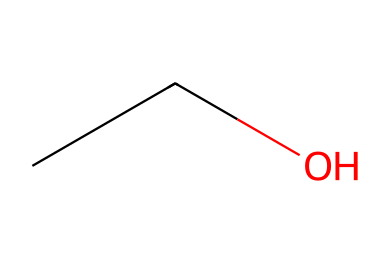What is the full name of this chemical? The SMILES representation "CCO" corresponds to the chemical structure of ethanol, which consists of two carbon atoms, five hydrogen atoms, and one oxygen atom.
Answer: ethanol How many carbon atoms are in this structure? The SMILES "CCO" indicates there are two 'C' characters, representing two carbon atoms in the structure of ethanol.
Answer: 2 How many hydrogen atoms are present in this chemical? From the SMILES notation "CCO", the two carbon atoms are fully saturated with hydrogen atoms; therefore, there are six hydrogen atoms in total because the formula for ethanol is C2H6O.
Answer: 6 What type of alcohol is this? Ethanol, derived from the given SMILES "CCO", is classified as a primary alcohol due to the -OH group being attached to a carbon atom that is only bonded to one other carbon atom.
Answer: primary Is this chemical polar or nonpolar? The presence of the -OH group in ethanol indicates it has a polar nature since this functional group can form hydrogen bonds, distinguishing it as polar.
Answer: polar What functional group does this molecule contain? The structure "CCO" shows that there is a hydroxyl group (-OH) attached to one of the carbon atoms, making the functional group present a hydroxyl group.
Answer: hydroxyl How many total atoms are present in this molecule? Counting the atoms in the SMILES "CCO", we have 2 carbon atoms, 6 hydrogen atoms, and 1 oxygen atom, resulting in a total of 9 atoms in the ethanol molecule.
Answer: 9 